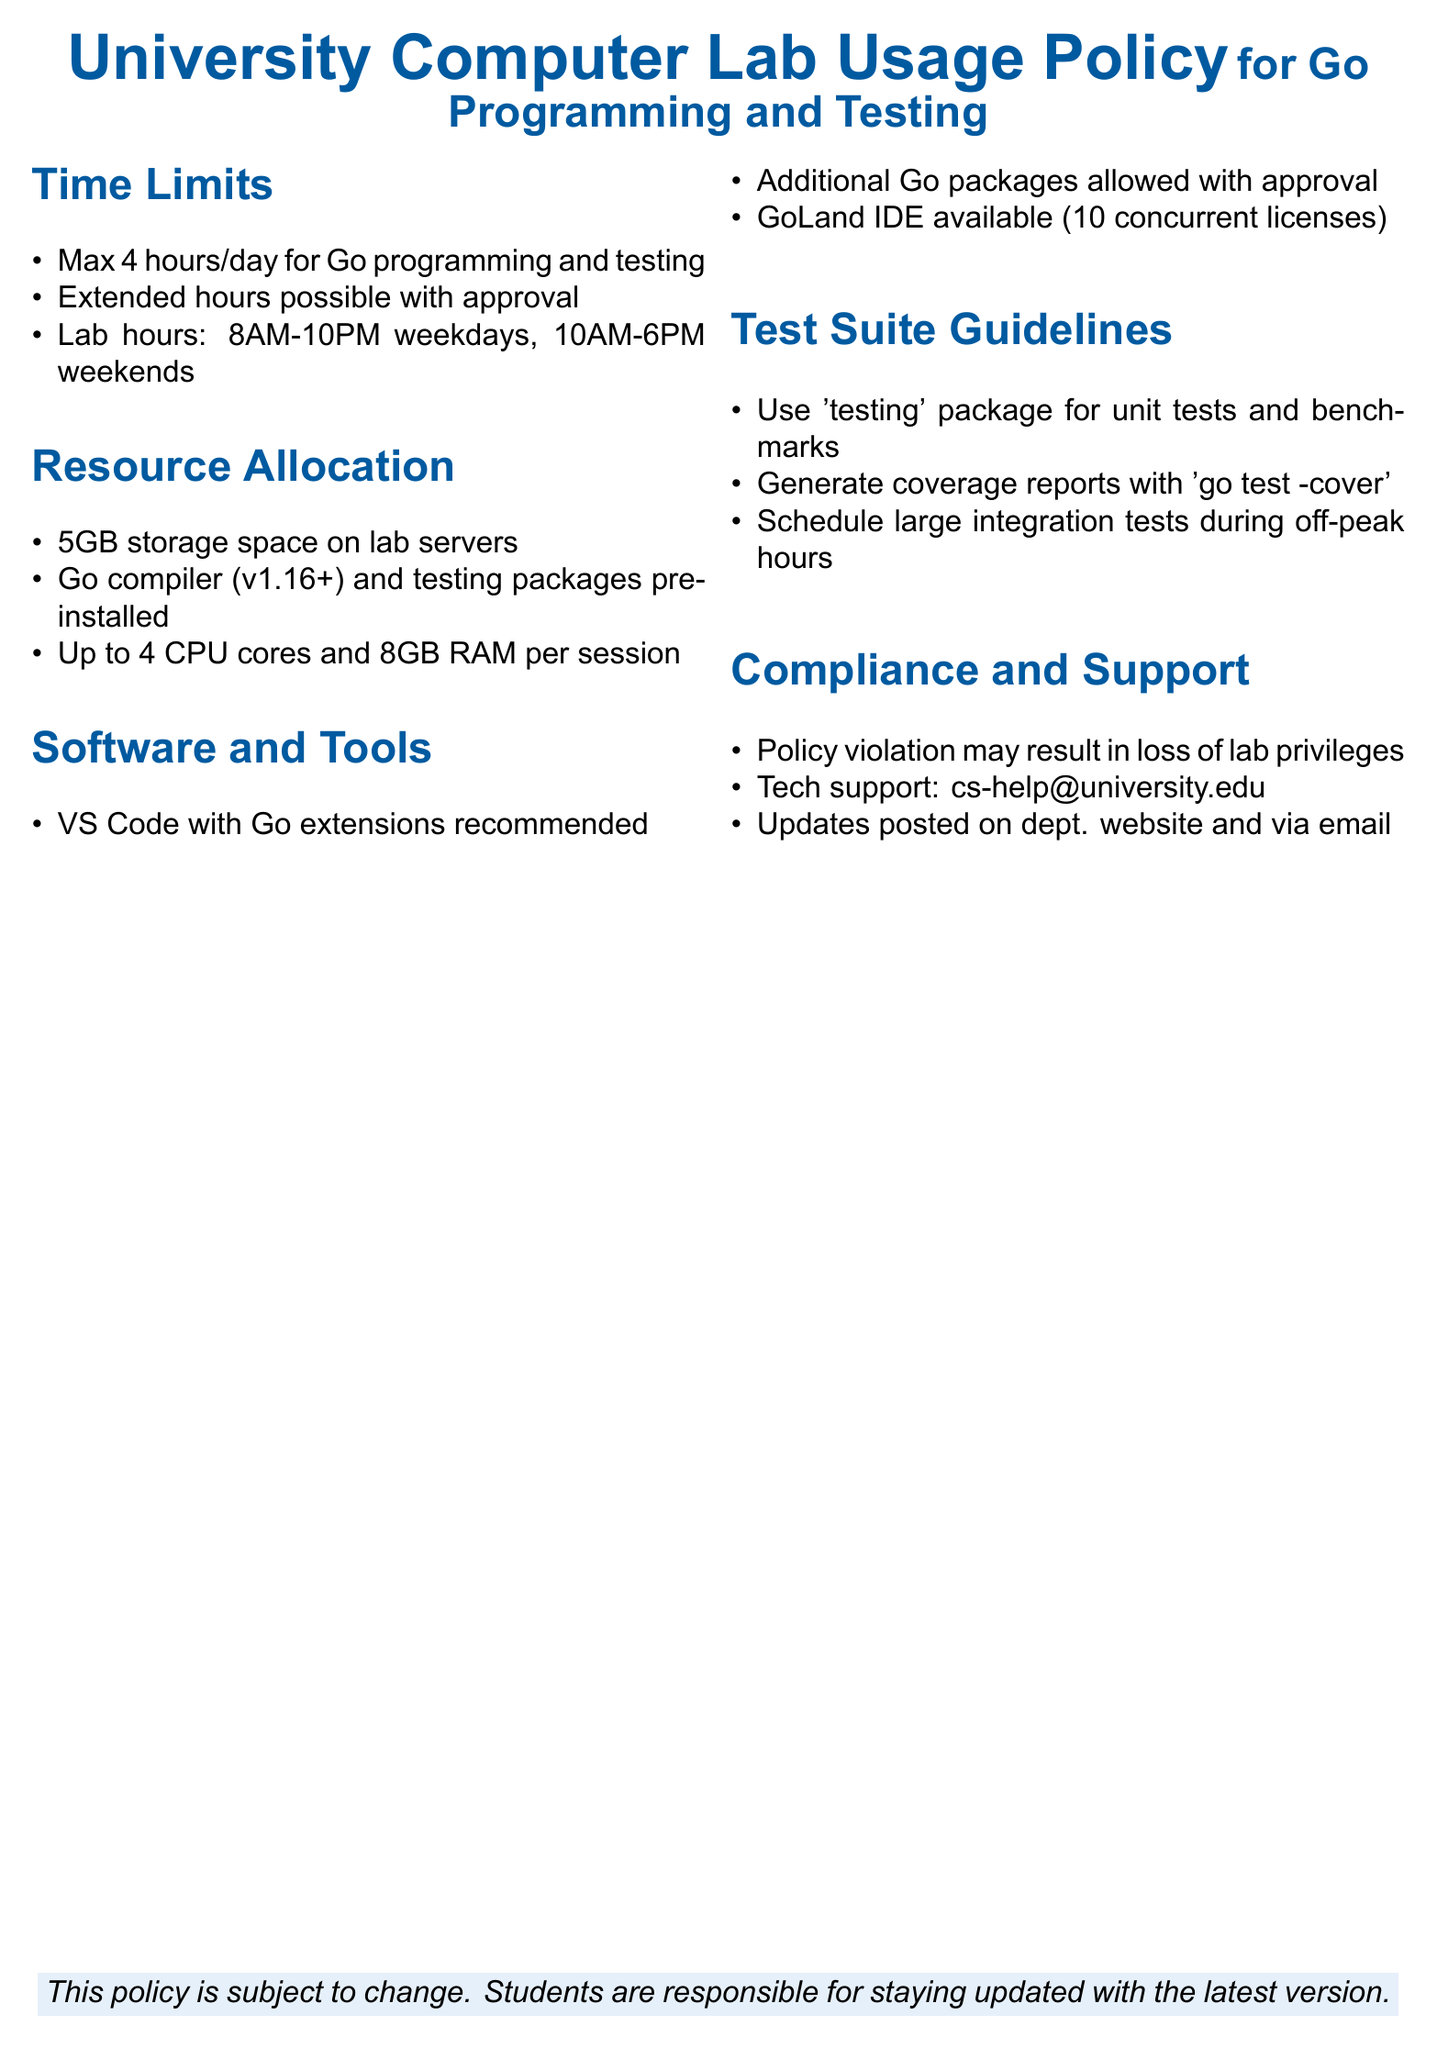What is the maximum time limit for lab usage per day? The maximum time limit for lab usage is specified in the Time Limits section as 4 hours per day.
Answer: 4 hours What are the lab hours on weekdays? The lab hours for weekdays are mentioned in the Time Limits section as 8AM to 10PM.
Answer: 8AM-10PM How much storage space is allocated on lab servers? The Resource Allocation section specifies that students have access to 5GB of storage space on lab servers.
Answer: 5GB How many CPU cores are available per session? The Resource Allocation section states that up to 4 CPU cores are allowed per session.
Answer: 4 CPU cores What is the email for technical support? The Compliance and Support section provides the email for technical support, which is cs-help@university.edu.
Answer: cs-help@university.edu What package is required for unit tests? The Test Suite Guidelines section specifies that the 'testing' package should be used for unit tests and benchmarks.
Answer: 'testing' package How many concurrent licenses are available for GoLand IDE? The Software and Tools section mentions that there are 10 concurrent licenses available for GoLand IDE.
Answer: 10 concurrent licenses What is the consequence of policy violation? The Compliance and Support section states that a policy violation may result in loss of lab privileges.
Answer: Loss of lab privileges During what hours should large integration tests be scheduled? The Test Suite Guidelines state that large integration tests should be scheduled during off-peak hours.
Answer: Off-peak hours 